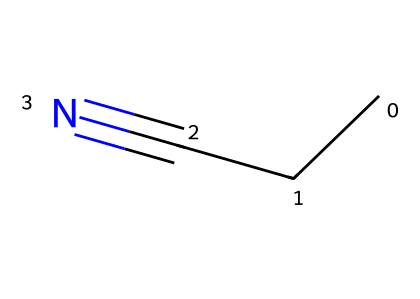What is the common name for the chemical represented by this SMILES? The SMILES representation "CCC#N" indicates a three-carbon chain (CCC) attached to a nitrile group (#N), making it known as propionitrile.
Answer: propionitrile How many carbon atoms are in propionitrile? The "CCC" in the SMILES indicates there are three carbon atoms in the structure.
Answer: three What type of functional group is present in propionitrile? The presence of the "#N" indicates a nitrile functional group, characteristic of this compound.
Answer: nitrile What is the total number of hydrogen atoms in propionitrile? With three carbons, the formula can be deduced to be C3H5N, meaning there are five hydrogen atoms in total.
Answer: five Which part of the structure contributes to its polarity? The presence of the nitrile group (-C≡N) introduces a dipole due to the difference in electronegativity between carbon and nitrogen.
Answer: nitrile group What is the primary use of propionitrile? Propionitrile is commonly used in organic synthesis and as a solvent in spectroscopy, which highlights its versatility in chemical applications.
Answer: organic synthesis and solvent What is the molecular formula of propionitrile? From its structure C3H5N can be derived, accounting for three carbons, five hydrogens, and one nitrogen.
Answer: C3H5N 